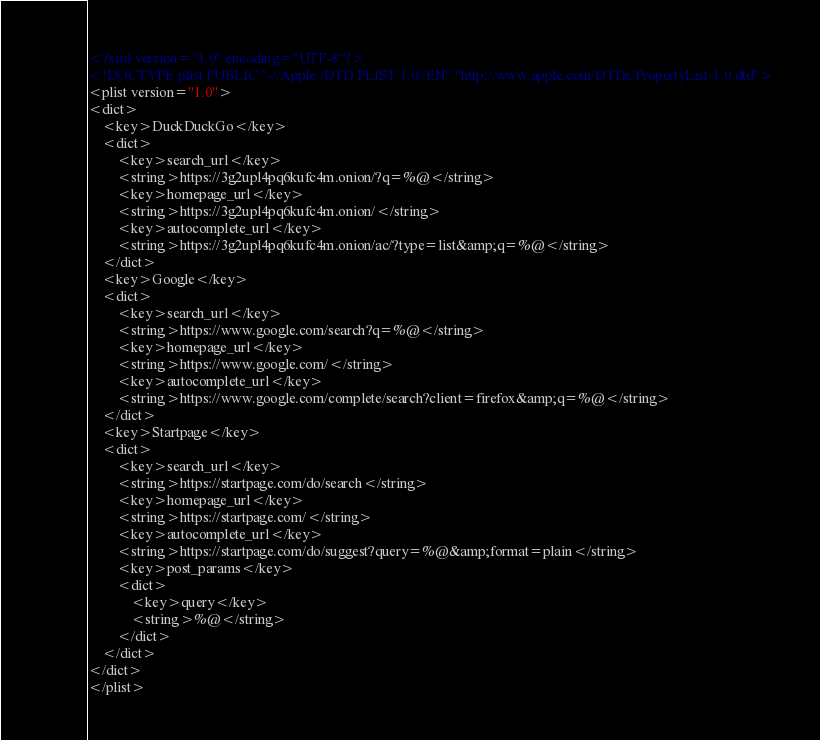<code> <loc_0><loc_0><loc_500><loc_500><_XML_><?xml version="1.0" encoding="UTF-8"?>
<!DOCTYPE plist PUBLIC "-//Apple//DTD PLIST 1.0//EN" "http://www.apple.com/DTDs/PropertyList-1.0.dtd">
<plist version="1.0">
<dict>
	<key>DuckDuckGo</key>
	<dict>
		<key>search_url</key>
		<string>https://3g2upl4pq6kufc4m.onion/?q=%@</string>
		<key>homepage_url</key>
		<string>https://3g2upl4pq6kufc4m.onion/</string>
		<key>autocomplete_url</key>
		<string>https://3g2upl4pq6kufc4m.onion/ac/?type=list&amp;q=%@</string>
	</dict>
	<key>Google</key>
	<dict>
		<key>search_url</key>
		<string>https://www.google.com/search?q=%@</string>
		<key>homepage_url</key>
		<string>https://www.google.com/</string>
		<key>autocomplete_url</key>
		<string>https://www.google.com/complete/search?client=firefox&amp;q=%@</string>
	</dict>
	<key>Startpage</key>
	<dict>
		<key>search_url</key>
		<string>https://startpage.com/do/search</string>
		<key>homepage_url</key>
		<string>https://startpage.com/</string>
		<key>autocomplete_url</key>
		<string>https://startpage.com/do/suggest?query=%@&amp;format=plain</string>
		<key>post_params</key>
		<dict>
			<key>query</key>
			<string>%@</string>
		</dict>
	</dict>
</dict>
</plist>
</code> 